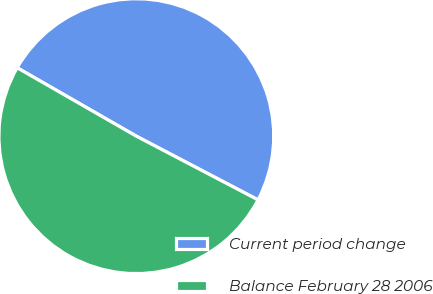<chart> <loc_0><loc_0><loc_500><loc_500><pie_chart><fcel>Current period change<fcel>Balance February 28 2006<nl><fcel>49.38%<fcel>50.62%<nl></chart> 